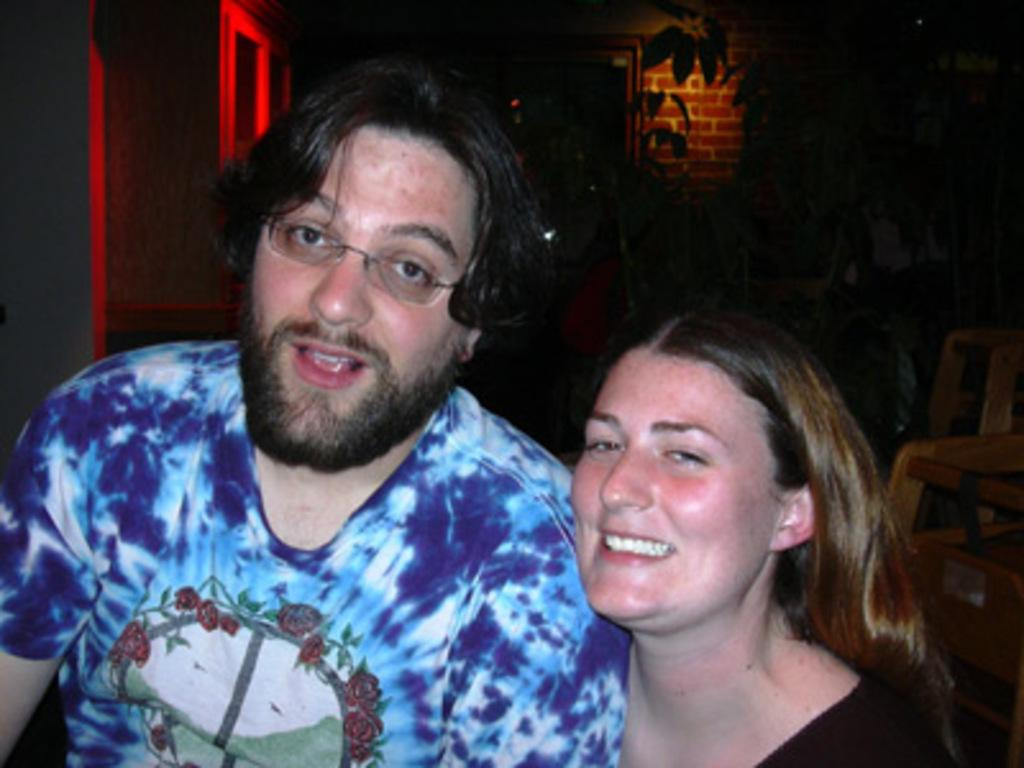How many people are present in the image? There are two people, a man and a woman, present in the image. What expressions do the man and woman have in the image? Both the man and the woman are smiling in the image. What can be seen on the right side of the image? There is a wooden object on the right side of the image. What type of vegetation is visible in the background of the image? There is a plant in the background of the image. What is visible in the background of the image besides the plant? There is a wall in the background of the image. What type of seed is being planted in the country shown in the image? There is no seed or country present in the image; it features a man, a woman, and various objects and elements in the background. 